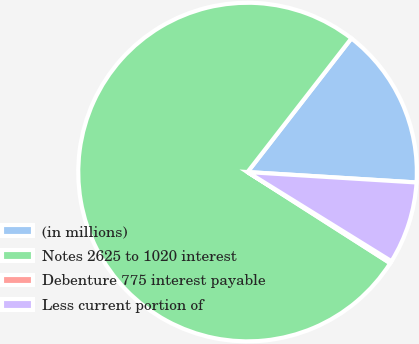Convert chart. <chart><loc_0><loc_0><loc_500><loc_500><pie_chart><fcel>(in millions)<fcel>Notes 2625 to 1020 interest<fcel>Debenture 775 interest payable<fcel>Less current portion of<nl><fcel>15.47%<fcel>76.46%<fcel>0.22%<fcel>7.85%<nl></chart> 